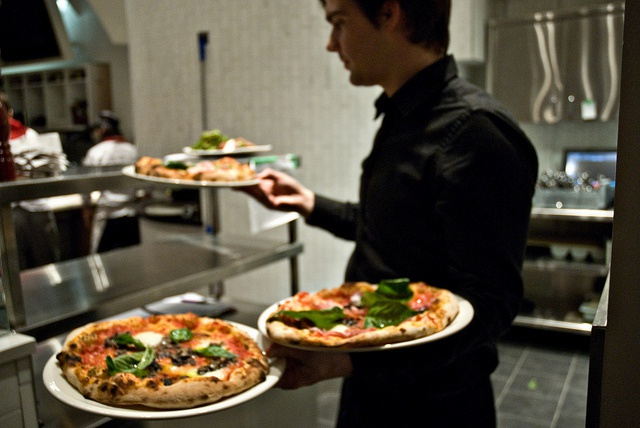Describe the objects in this image and their specific colors. I can see people in black, maroon, and gray tones, pizza in black, brown, orange, olive, and maroon tones, pizza in black, olive, orange, and tan tones, pizza in black, tan, ivory, and olive tones, and people in black, lightgray, darkgray, and maroon tones in this image. 